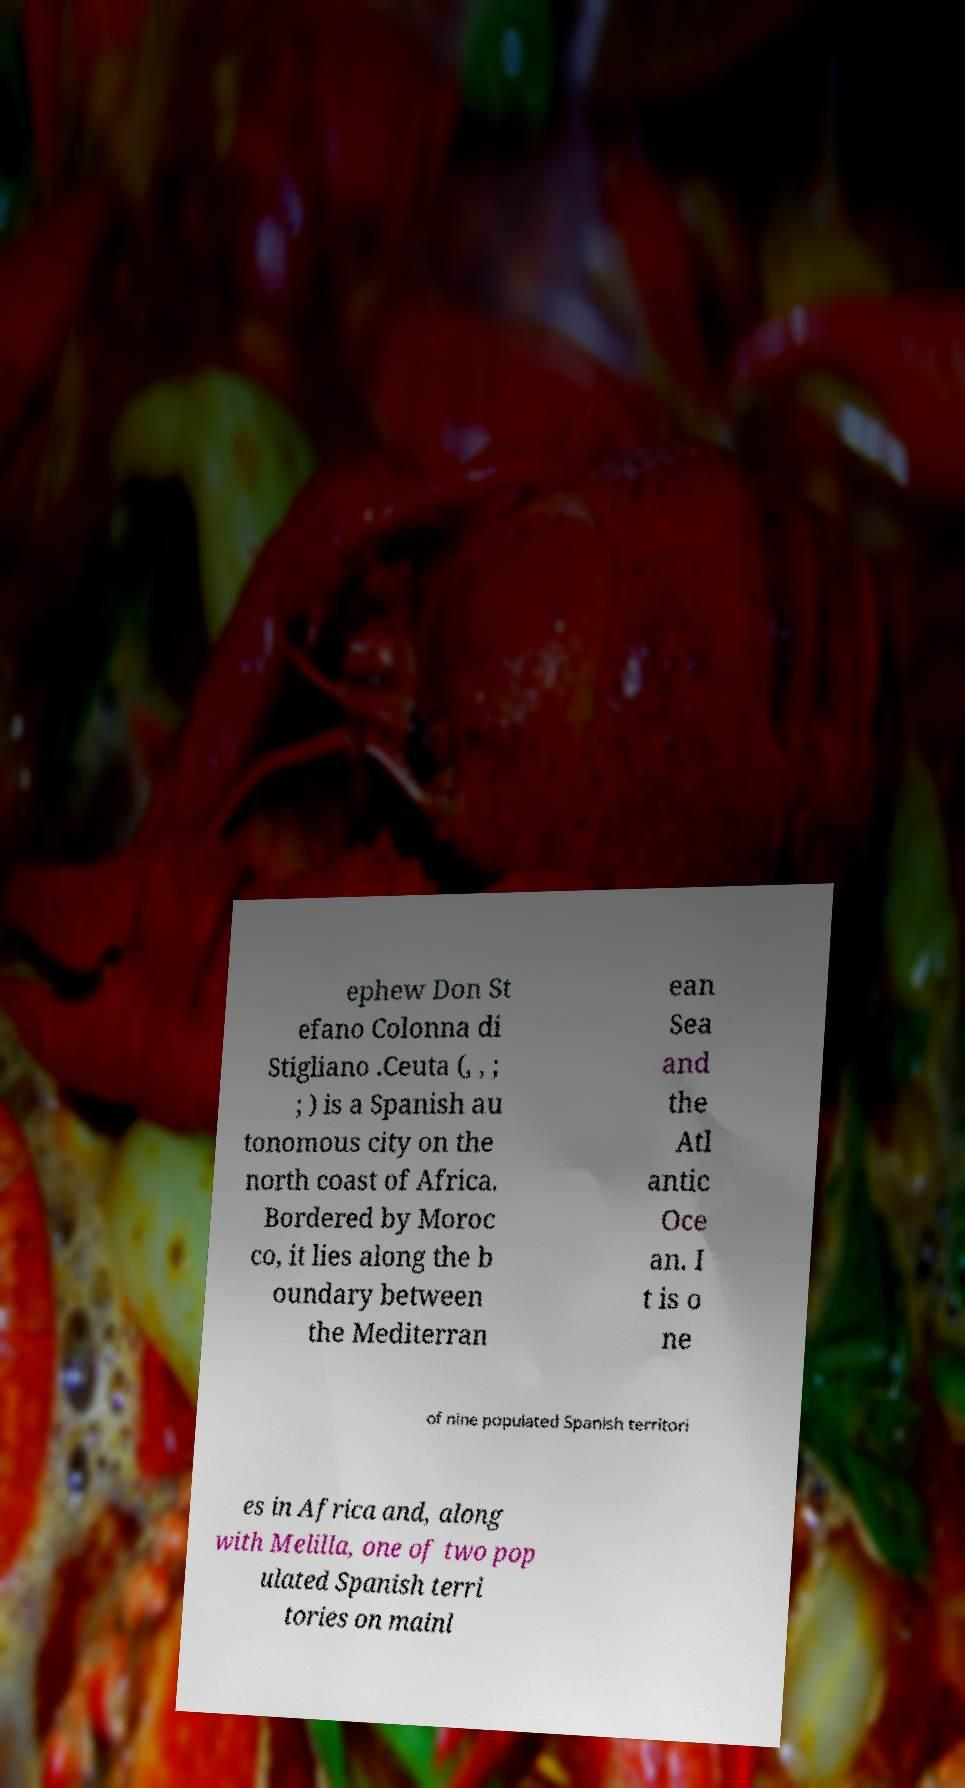What messages or text are displayed in this image? I need them in a readable, typed format. ephew Don St efano Colonna di Stigliano .Ceuta (, , ; ; ) is a Spanish au tonomous city on the north coast of Africa. Bordered by Moroc co, it lies along the b oundary between the Mediterran ean Sea and the Atl antic Oce an. I t is o ne of nine populated Spanish territori es in Africa and, along with Melilla, one of two pop ulated Spanish terri tories on mainl 